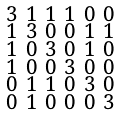<formula> <loc_0><loc_0><loc_500><loc_500>\begin{smallmatrix} 3 & 1 & 1 & 1 & 0 & 0 \\ 1 & 3 & 0 & 0 & 1 & 1 \\ 1 & 0 & 3 & 0 & 1 & 0 \\ 1 & 0 & 0 & 3 & 0 & 0 \\ 0 & 1 & 1 & 0 & 3 & 0 \\ 0 & 1 & 0 & 0 & 0 & 3 \end{smallmatrix}</formula> 